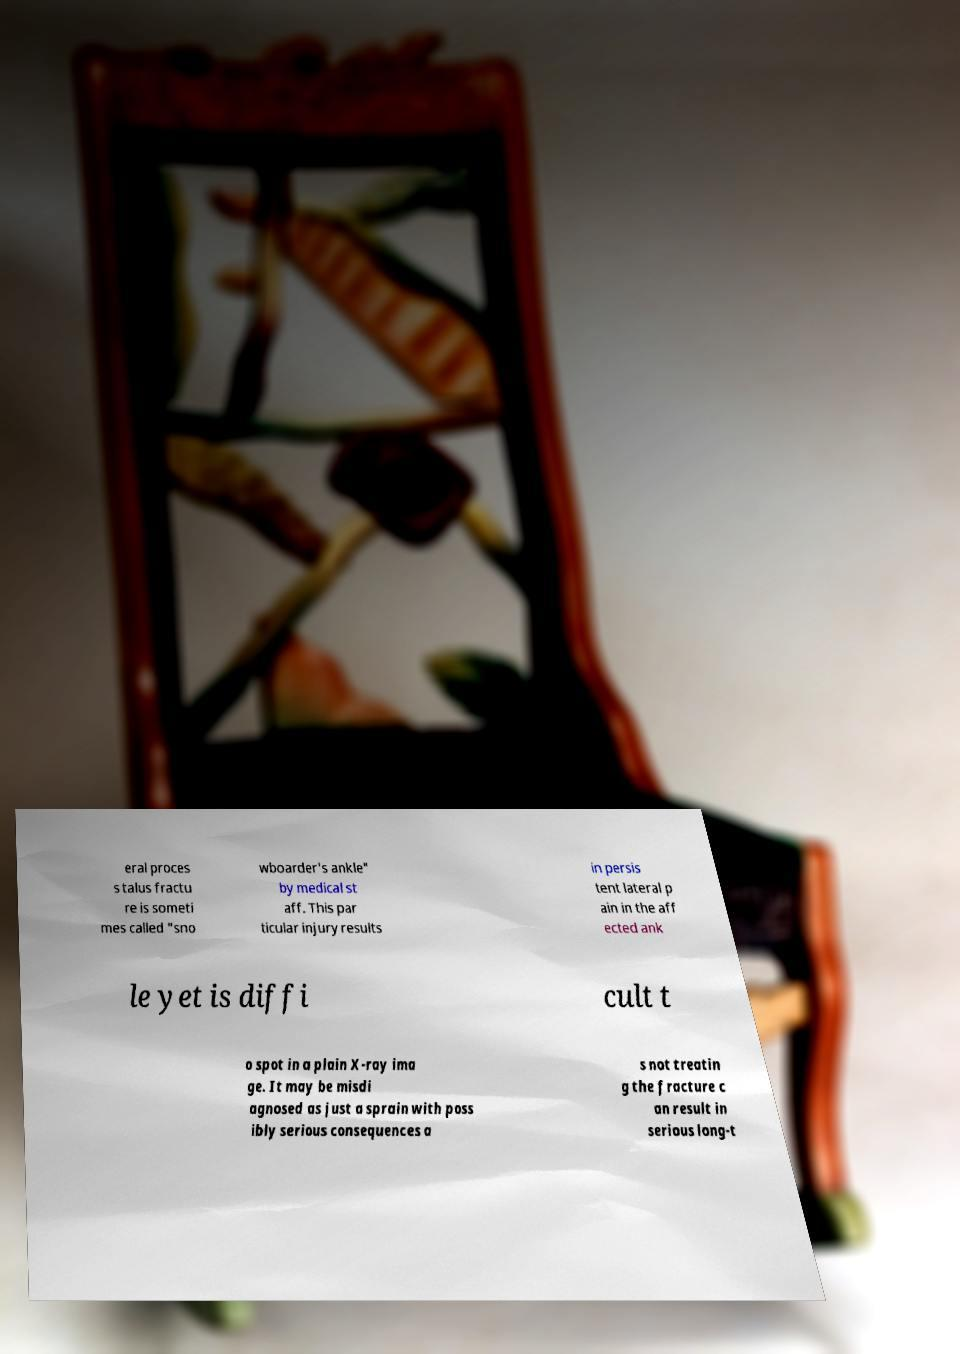Can you read and provide the text displayed in the image?This photo seems to have some interesting text. Can you extract and type it out for me? eral proces s talus fractu re is someti mes called "sno wboarder's ankle" by medical st aff. This par ticular injury results in persis tent lateral p ain in the aff ected ank le yet is diffi cult t o spot in a plain X-ray ima ge. It may be misdi agnosed as just a sprain with poss ibly serious consequences a s not treatin g the fracture c an result in serious long-t 